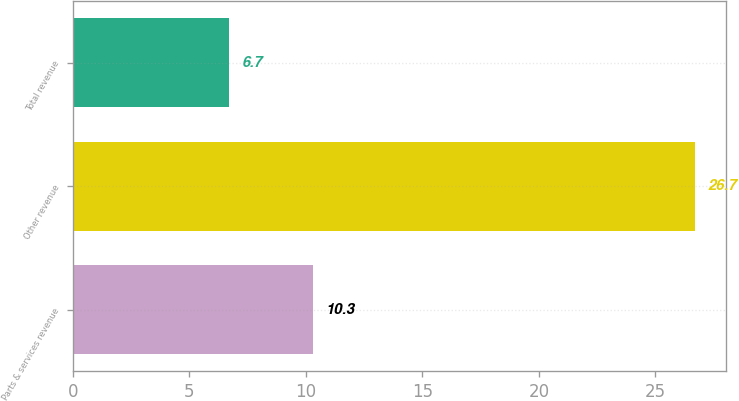Convert chart to OTSL. <chart><loc_0><loc_0><loc_500><loc_500><bar_chart><fcel>Parts & services revenue<fcel>Other revenue<fcel>Total revenue<nl><fcel>10.3<fcel>26.7<fcel>6.7<nl></chart> 